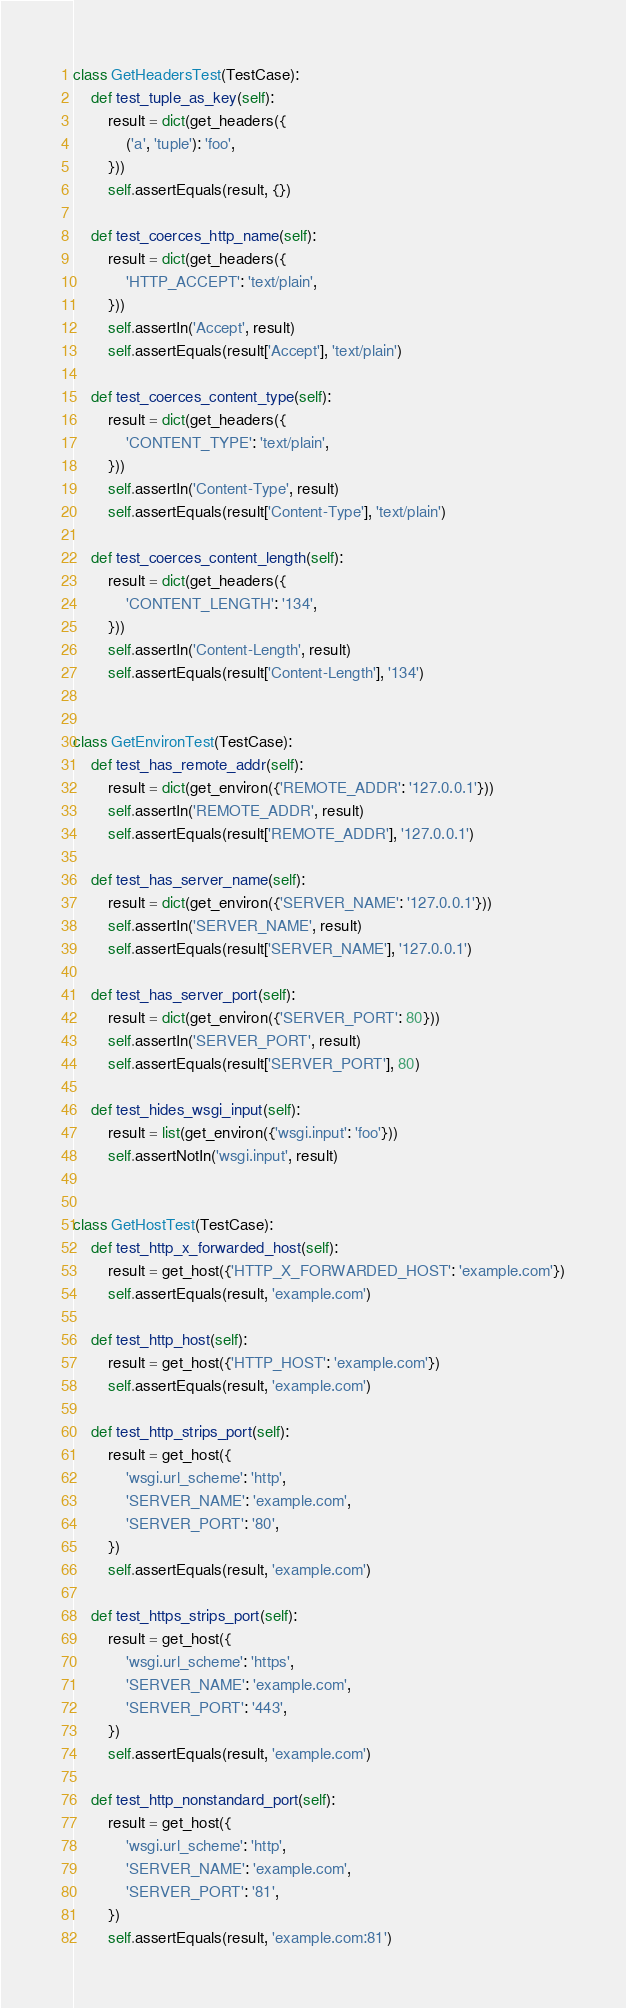Convert code to text. <code><loc_0><loc_0><loc_500><loc_500><_Python_>
class GetHeadersTest(TestCase):
    def test_tuple_as_key(self):
        result = dict(get_headers({
            ('a', 'tuple'): 'foo',
        }))
        self.assertEquals(result, {})

    def test_coerces_http_name(self):
        result = dict(get_headers({
            'HTTP_ACCEPT': 'text/plain',
        }))
        self.assertIn('Accept', result)
        self.assertEquals(result['Accept'], 'text/plain')

    def test_coerces_content_type(self):
        result = dict(get_headers({
            'CONTENT_TYPE': 'text/plain',
        }))
        self.assertIn('Content-Type', result)
        self.assertEquals(result['Content-Type'], 'text/plain')

    def test_coerces_content_length(self):
        result = dict(get_headers({
            'CONTENT_LENGTH': '134',
        }))
        self.assertIn('Content-Length', result)
        self.assertEquals(result['Content-Length'], '134')


class GetEnvironTest(TestCase):
    def test_has_remote_addr(self):
        result = dict(get_environ({'REMOTE_ADDR': '127.0.0.1'}))
        self.assertIn('REMOTE_ADDR', result)
        self.assertEquals(result['REMOTE_ADDR'], '127.0.0.1')

    def test_has_server_name(self):
        result = dict(get_environ({'SERVER_NAME': '127.0.0.1'}))
        self.assertIn('SERVER_NAME', result)
        self.assertEquals(result['SERVER_NAME'], '127.0.0.1')

    def test_has_server_port(self):
        result = dict(get_environ({'SERVER_PORT': 80}))
        self.assertIn('SERVER_PORT', result)
        self.assertEquals(result['SERVER_PORT'], 80)

    def test_hides_wsgi_input(self):
        result = list(get_environ({'wsgi.input': 'foo'}))
        self.assertNotIn('wsgi.input', result)


class GetHostTest(TestCase):
    def test_http_x_forwarded_host(self):
        result = get_host({'HTTP_X_FORWARDED_HOST': 'example.com'})
        self.assertEquals(result, 'example.com')

    def test_http_host(self):
        result = get_host({'HTTP_HOST': 'example.com'})
        self.assertEquals(result, 'example.com')

    def test_http_strips_port(self):
        result = get_host({
            'wsgi.url_scheme': 'http',
            'SERVER_NAME': 'example.com',
            'SERVER_PORT': '80',
        })
        self.assertEquals(result, 'example.com')

    def test_https_strips_port(self):
        result = get_host({
            'wsgi.url_scheme': 'https',
            'SERVER_NAME': 'example.com',
            'SERVER_PORT': '443',
        })
        self.assertEquals(result, 'example.com')

    def test_http_nonstandard_port(self):
        result = get_host({
            'wsgi.url_scheme': 'http',
            'SERVER_NAME': 'example.com',
            'SERVER_PORT': '81',
        })
        self.assertEquals(result, 'example.com:81')
</code> 